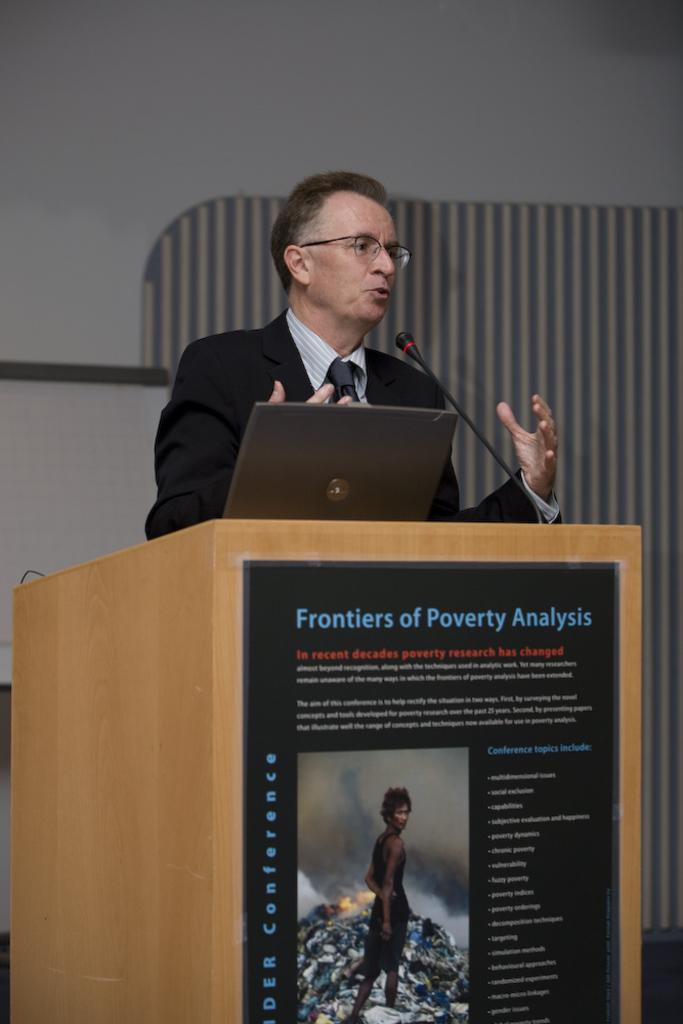What is the topic of the lecture?
Make the answer very short. Frontiers of poverty analysis. 